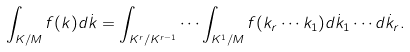Convert formula to latex. <formula><loc_0><loc_0><loc_500><loc_500>\int _ { K / M } f ( k ) d \dot { k } = \int _ { K ^ { r } / K ^ { r - 1 } } \cdots \int _ { K ^ { 1 } / M } f ( k _ { r } \cdots k _ { 1 } ) d \dot { k } _ { 1 } \cdots d \dot { k } _ { r } .</formula> 